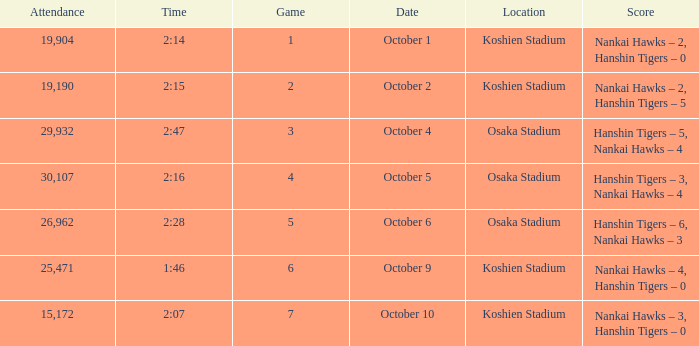How many games have an Attendance of 19,190? 1.0. 